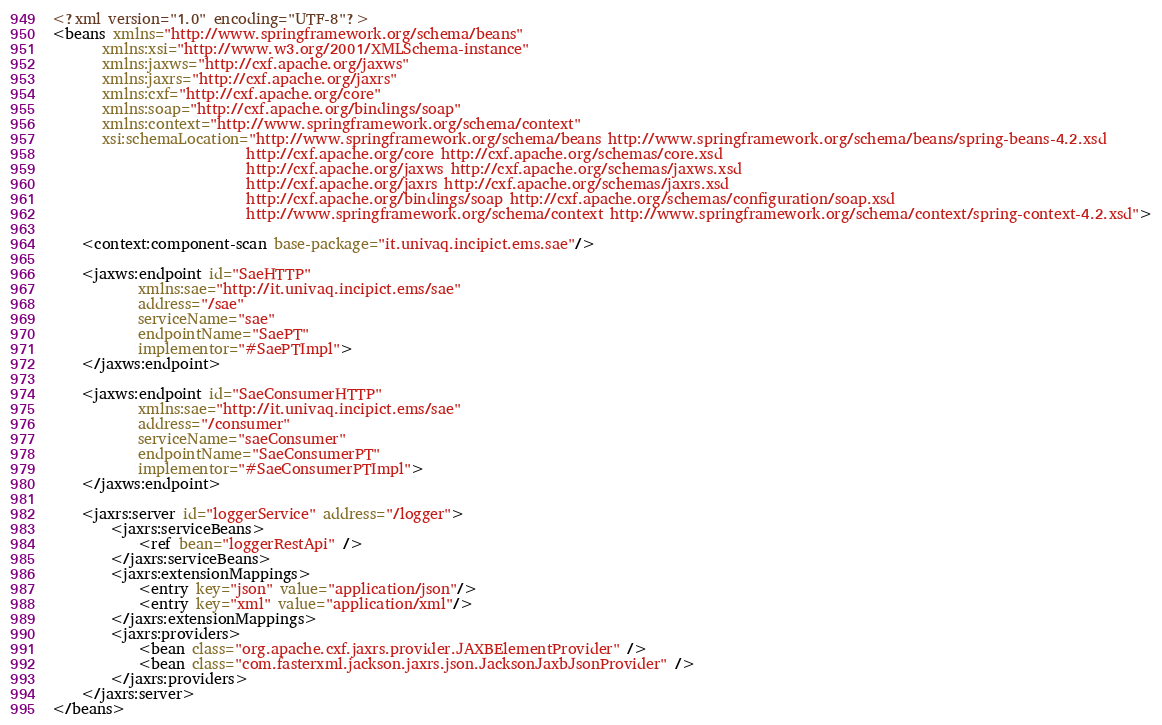Convert code to text. <code><loc_0><loc_0><loc_500><loc_500><_XML_><?xml version="1.0" encoding="UTF-8"?>
<beans xmlns="http://www.springframework.org/schema/beans" 
       xmlns:xsi="http://www.w3.org/2001/XMLSchema-instance" 
       xmlns:jaxws="http://cxf.apache.org/jaxws"
       xmlns:jaxrs="http://cxf.apache.org/jaxrs"
       xmlns:cxf="http://cxf.apache.org/core" 
       xmlns:soap="http://cxf.apache.org/bindings/soap"
       xmlns:context="http://www.springframework.org/schema/context"
       xsi:schemaLocation="http://www.springframework.org/schema/beans http://www.springframework.org/schema/beans/spring-beans-4.2.xsd 
                           http://cxf.apache.org/core http://cxf.apache.org/schemas/core.xsd 
                           http://cxf.apache.org/jaxws http://cxf.apache.org/schemas/jaxws.xsd
                           http://cxf.apache.org/jaxrs http://cxf.apache.org/schemas/jaxrs.xsd
                           http://cxf.apache.org/bindings/soap http://cxf.apache.org/schemas/configuration/soap.xsd
                           http://www.springframework.org/schema/context http://www.springframework.org/schema/context/spring-context-4.2.xsd">

	<context:component-scan base-package="it.univaq.incipict.ems.sae"/>

    <jaxws:endpoint id="SaeHTTP" 
			xmlns:sae="http://it.univaq.incipict.ems/sae"
		    address="/sae" 
		    serviceName="sae"
		    endpointName="SaePT" 
		    implementor="#SaePTImpl">		   
	</jaxws:endpoint>

    <jaxws:endpoint id="SaeConsumerHTTP" 
			xmlns:sae="http://it.univaq.incipict.ems/sae"
		    address="/consumer" 
		    serviceName="saeConsumer"
		    endpointName="SaeConsumerPT" 
		    implementor="#SaeConsumerPTImpl">		   
	</jaxws:endpoint>

	<jaxrs:server id="loggerService" address="/logger">
		<jaxrs:serviceBeans>
			<ref bean="loggerRestApi" />
		</jaxrs:serviceBeans>
	    <jaxrs:extensionMappings>
            <entry key="json" value="application/json"/>
            <entry key="xml" value="application/xml"/>
        </jaxrs:extensionMappings>
        <jaxrs:providers>
            <bean class="org.apache.cxf.jaxrs.provider.JAXBElementProvider" />
            <bean class="com.fasterxml.jackson.jaxrs.json.JacksonJaxbJsonProvider" />
        </jaxrs:providers>
  	</jaxrs:server>
</beans></code> 